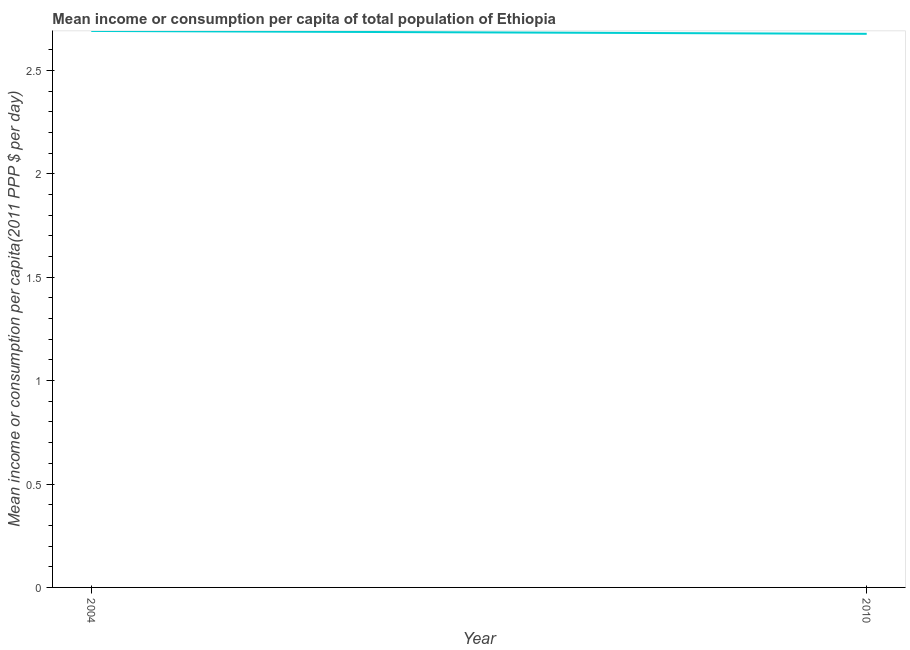What is the mean income or consumption in 2004?
Your answer should be very brief. 2.69. Across all years, what is the maximum mean income or consumption?
Give a very brief answer. 2.69. Across all years, what is the minimum mean income or consumption?
Your answer should be very brief. 2.68. In which year was the mean income or consumption minimum?
Offer a terse response. 2010. What is the sum of the mean income or consumption?
Your response must be concise. 5.37. What is the difference between the mean income or consumption in 2004 and 2010?
Offer a terse response. 0.01. What is the average mean income or consumption per year?
Your answer should be very brief. 2.68. What is the median mean income or consumption?
Make the answer very short. 2.68. What is the ratio of the mean income or consumption in 2004 to that in 2010?
Give a very brief answer. 1.01. Is the mean income or consumption in 2004 less than that in 2010?
Ensure brevity in your answer.  No. In how many years, is the mean income or consumption greater than the average mean income or consumption taken over all years?
Ensure brevity in your answer.  1. Does the mean income or consumption monotonically increase over the years?
Your answer should be very brief. No. What is the difference between two consecutive major ticks on the Y-axis?
Offer a terse response. 0.5. Does the graph contain any zero values?
Provide a succinct answer. No. What is the title of the graph?
Give a very brief answer. Mean income or consumption per capita of total population of Ethiopia. What is the label or title of the Y-axis?
Offer a very short reply. Mean income or consumption per capita(2011 PPP $ per day). What is the Mean income or consumption per capita(2011 PPP $ per day) of 2004?
Offer a terse response. 2.69. What is the Mean income or consumption per capita(2011 PPP $ per day) in 2010?
Offer a terse response. 2.68. What is the difference between the Mean income or consumption per capita(2011 PPP $ per day) in 2004 and 2010?
Offer a terse response. 0.01. 